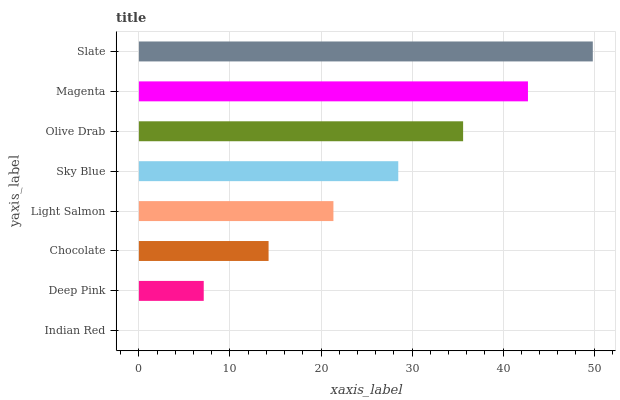Is Indian Red the minimum?
Answer yes or no. Yes. Is Slate the maximum?
Answer yes or no. Yes. Is Deep Pink the minimum?
Answer yes or no. No. Is Deep Pink the maximum?
Answer yes or no. No. Is Deep Pink greater than Indian Red?
Answer yes or no. Yes. Is Indian Red less than Deep Pink?
Answer yes or no. Yes. Is Indian Red greater than Deep Pink?
Answer yes or no. No. Is Deep Pink less than Indian Red?
Answer yes or no. No. Is Sky Blue the high median?
Answer yes or no. Yes. Is Light Salmon the low median?
Answer yes or no. Yes. Is Deep Pink the high median?
Answer yes or no. No. Is Magenta the low median?
Answer yes or no. No. 